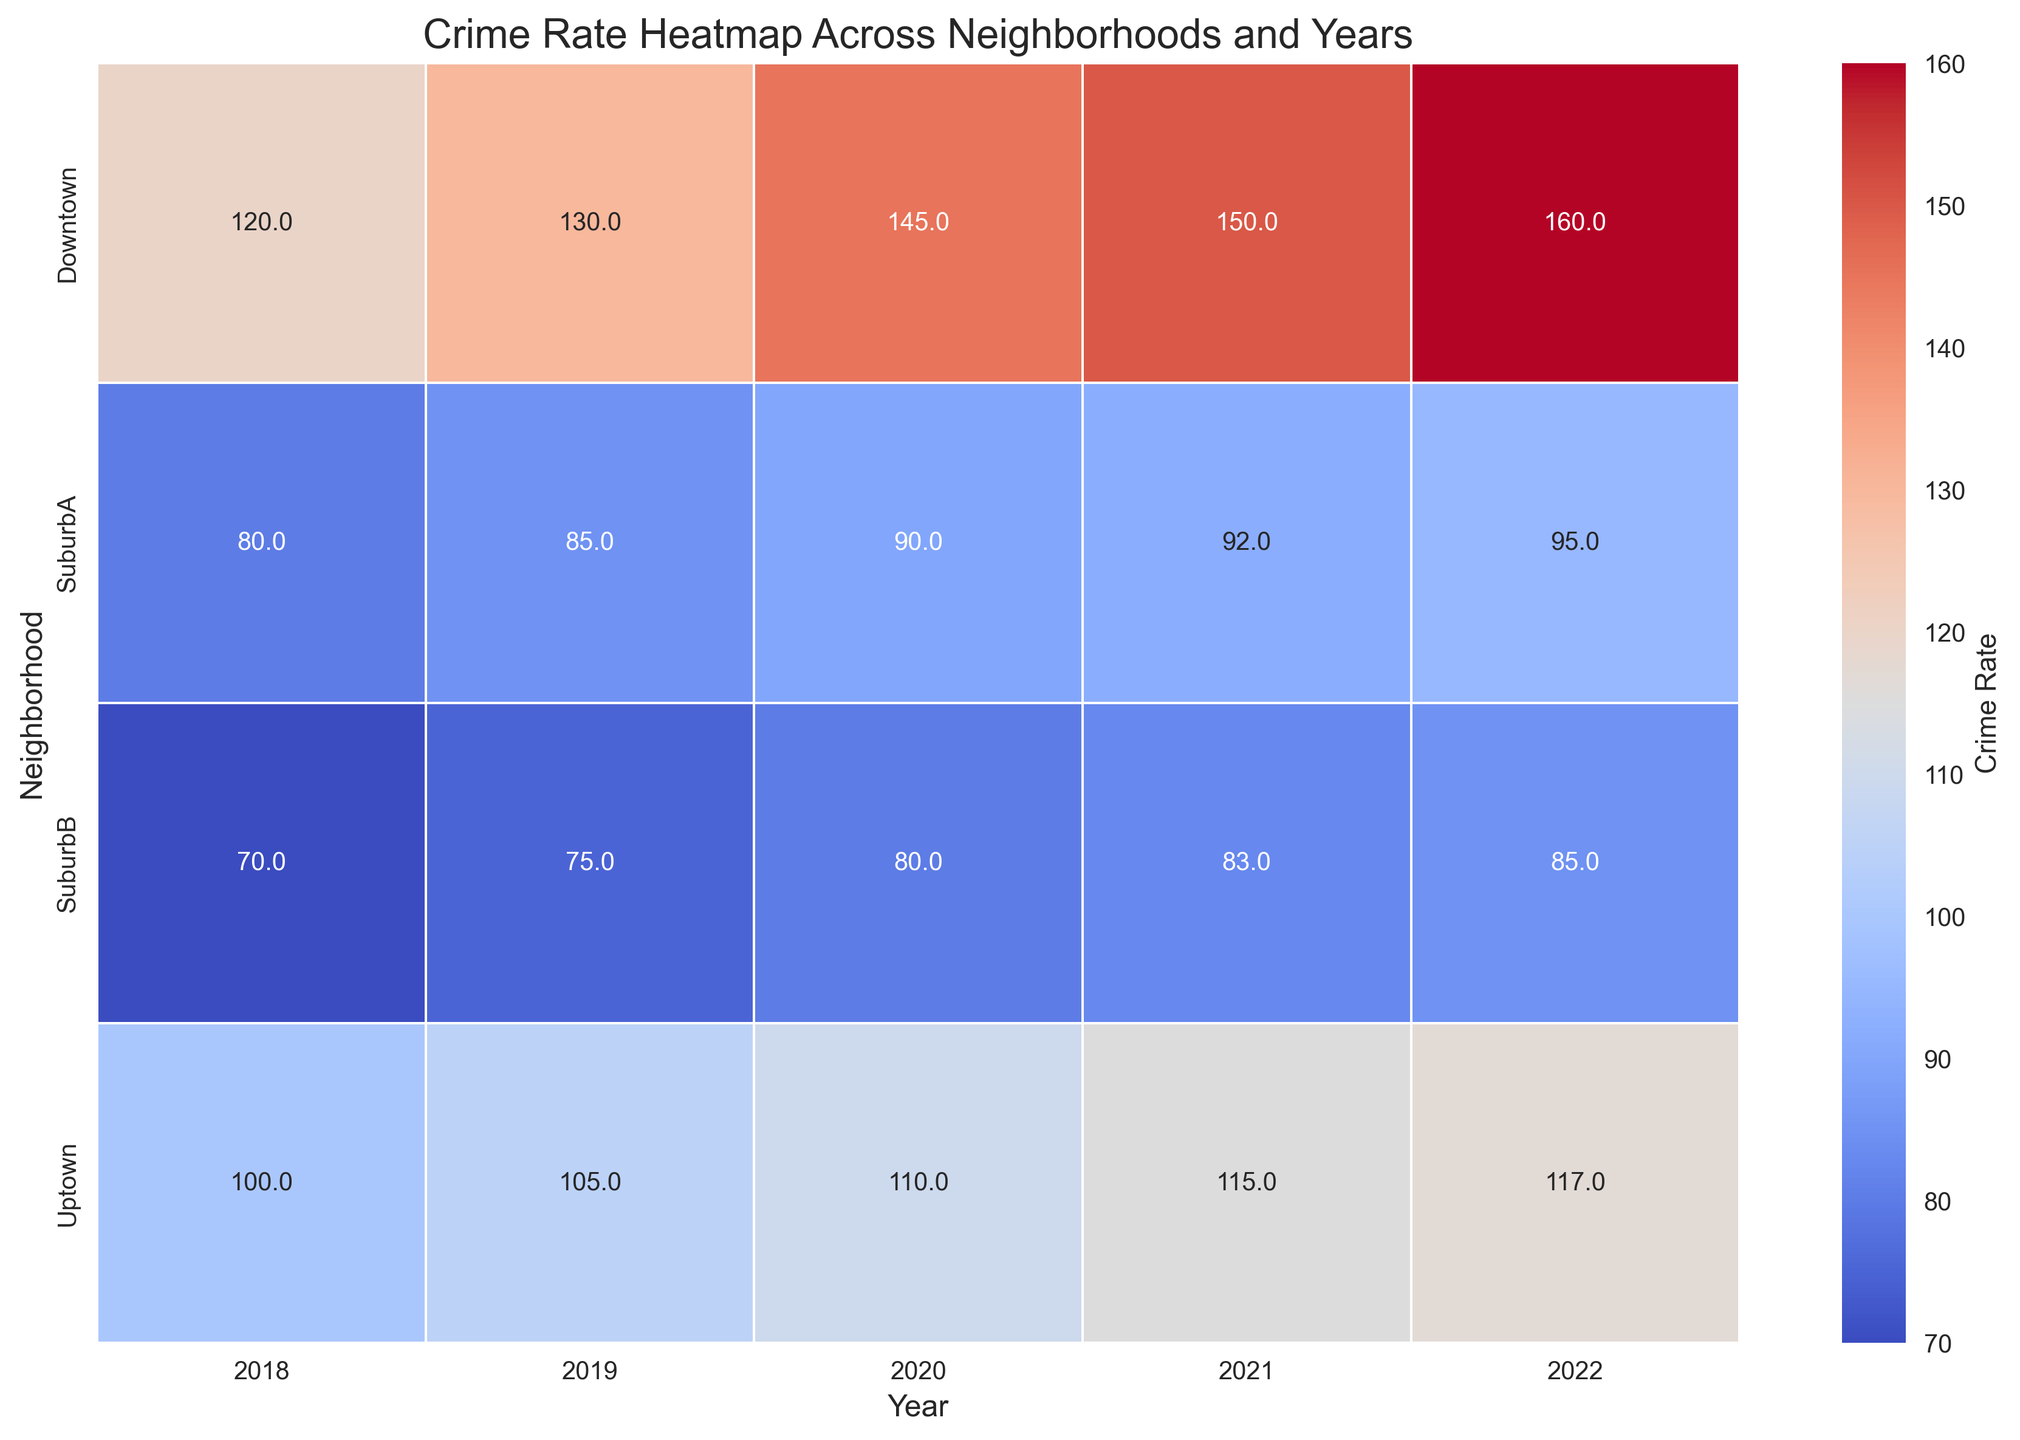What was the crime rate in Downtown in 2020? Locate the cell corresponding to Downtown in the row and 2020 in the column. The crime rate is 145.
Answer: 145 Which year did Uptown have the lowest crime rate and what was it? Scan the Uptown row to find the lowest value and note its corresponding year. The lowest crime rate was in 2018 with a value of 100.
Answer: 2018, 100 Did the crime rate in SuburbA increase or decrease from 2018 to 2022, and by how much? Compare the values for SuburbA in 2018 (80) and 2022 (95). Calculate the difference: 95 - 80 = 15. Therefore, it increased by 15.
Answer: Increased by 15 Which neighborhood saw the highest increase in crime rate from 2018 to 2022 and what was the increase? Calculate the change for each neighborhood from 2018 to 2022: Downtown (160-120=40), SuburbA (95-80=15), SuburbB (85-70=15), and Uptown (117-100=17). The highest increase was in Downtown with 40.
Answer: Downtown, 40 Comparing the crime rates in Downtown and SuburbB in 2020, which neighborhood had the higher rate and by how much? Locate the 2020 values for Downtown (145) and SuburbB (80). The difference is 145 - 80 = 65; Downtown had the higher rate by 65.
Answer: Downtown by 65 What's the average crime rate for all neighborhoods in 2019? Sum the crime rates for 2019 across all neighborhoods (130 + 85 + 75 + 105 = 395) and divide by 4: 395 / 4 = 98.75.
Answer: 98.75 How did the crime rate trend for SuburbB change over the years 2018 to 2022? Observe the values in SuburbB over the years: They increased slightly from 70 in 2018 to 85 in 2022.
Answer: Increased In which year was the overall crime rate highest for all neighborhoods combined? Sum the crime rates for each year and find the highest: 
2018: 120+80+70+100=370, 
2019: 130+85+75+105=395, 
2020: 145+90+80+110=425, 
2021: 150+92+83+115=440, 
2022: 160+95+85+117=457. 
2022 has the highest combined crime rate.
Answer: 2022 What visual pattern do you observe in the heatmap for the crime rates in Downtown over the years? The cells for Downtown in each year show a noticeable gradual increase in crime rate, indicated by warm colors getting progressively stronger.
Answer: Gradual increase 